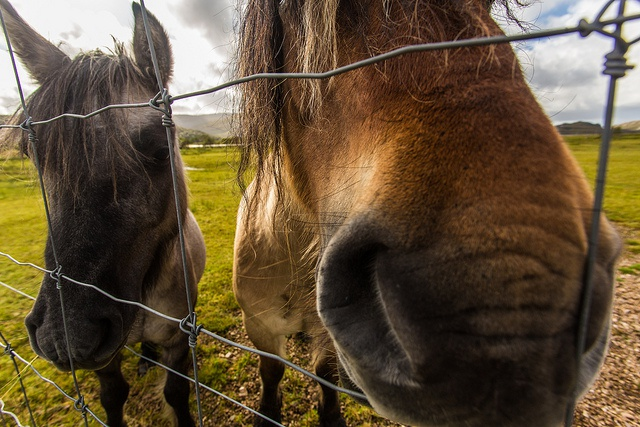Describe the objects in this image and their specific colors. I can see horse in gray, black, maroon, and olive tones and horse in gray and black tones in this image. 